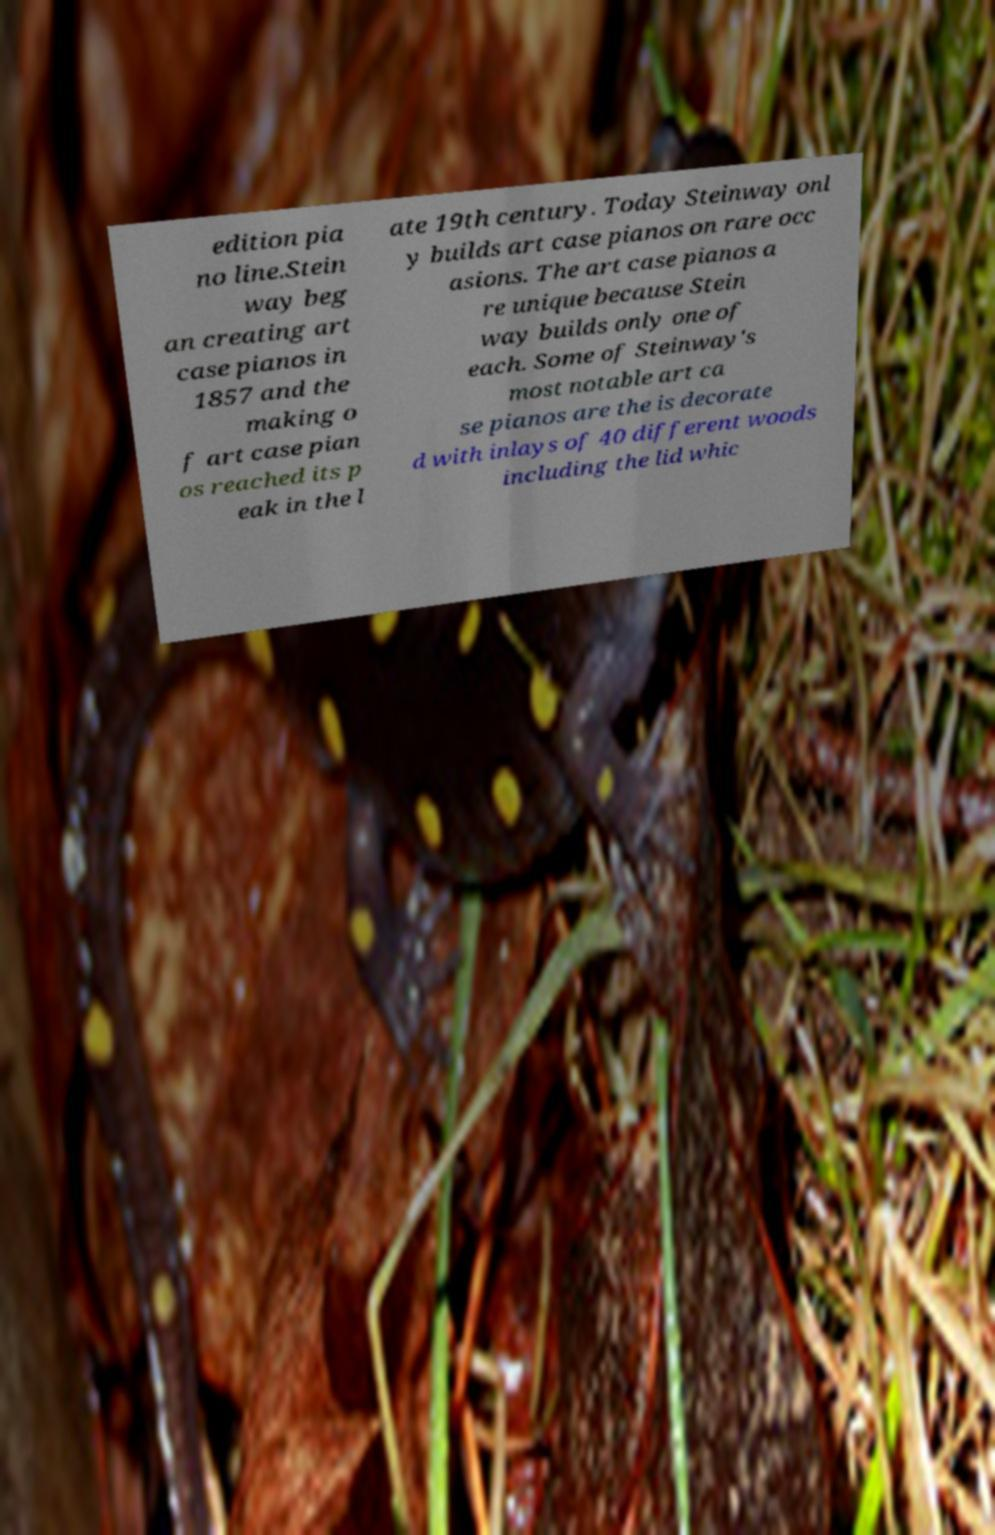Could you assist in decoding the text presented in this image and type it out clearly? edition pia no line.Stein way beg an creating art case pianos in 1857 and the making o f art case pian os reached its p eak in the l ate 19th century. Today Steinway onl y builds art case pianos on rare occ asions. The art case pianos a re unique because Stein way builds only one of each. Some of Steinway's most notable art ca se pianos are the is decorate d with inlays of 40 different woods including the lid whic 